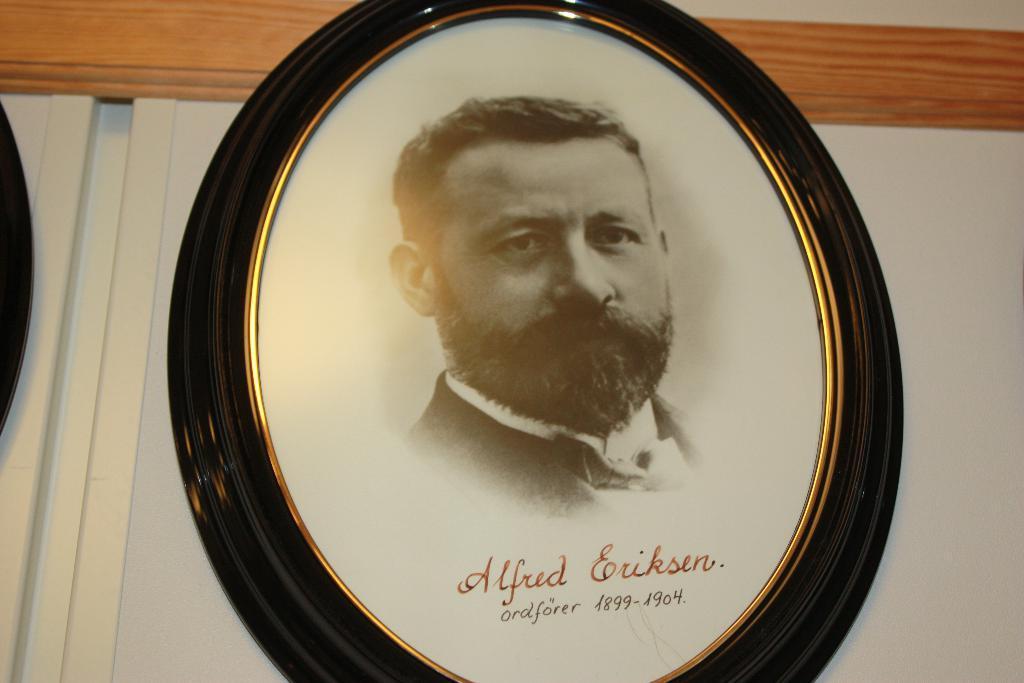Please provide a concise description of this image. In this picture, we see the photo frame of the man which is placed on the white wall. At the bottom of the photo, we see some text written on it. 